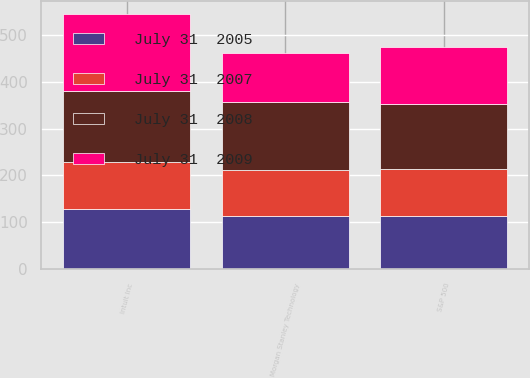<chart> <loc_0><loc_0><loc_500><loc_500><stacked_bar_chart><ecel><fcel>Intuit Inc<fcel>S&P 500<fcel>Morgan Stanley Technology<nl><fcel>July 31  2007<fcel>100<fcel>100<fcel>100<nl><fcel>July 31  2005<fcel>128.21<fcel>114.05<fcel>112.64<nl><fcel>July 31  2009<fcel>164.9<fcel>120.19<fcel>106.05<nl><fcel>July 31  2008<fcel>152.99<fcel>139.58<fcel>144.03<nl></chart> 